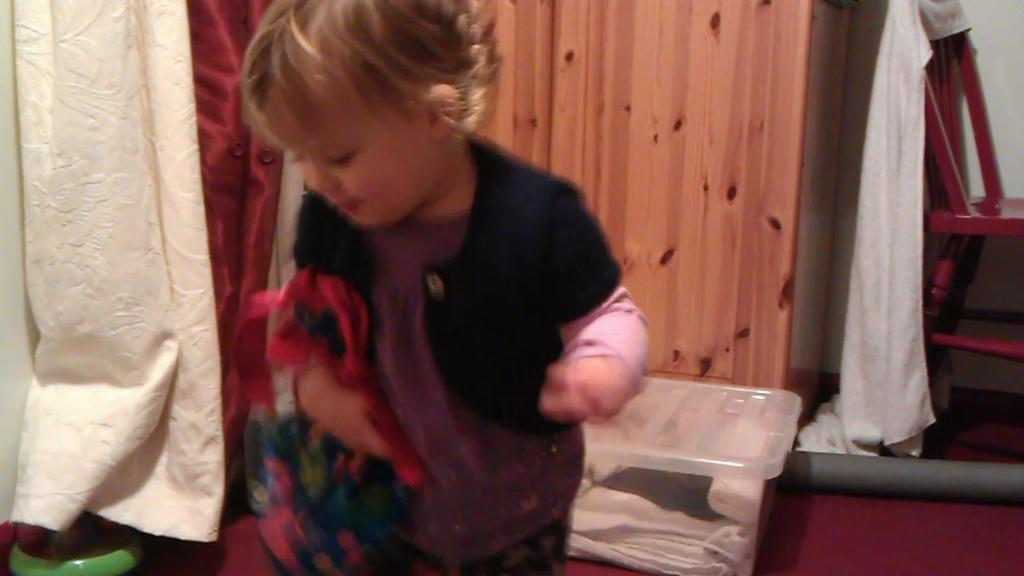What is the main subject in the foreground of the image? There is a boy in the foreground of the image. What is the boy holding in the image? The boy is holding clothes in the image. What can be seen in the background of the image? There are curtains, a cupboard, a box, cloth, a stool, and other objects in the background of the image. What type of hydrant is visible in the image? There is no hydrant present in the image. Can you tell me how the monkey is interacting with the boy in the image? There is no monkey present in the image; only the boy and various objects and elements can be seen. 